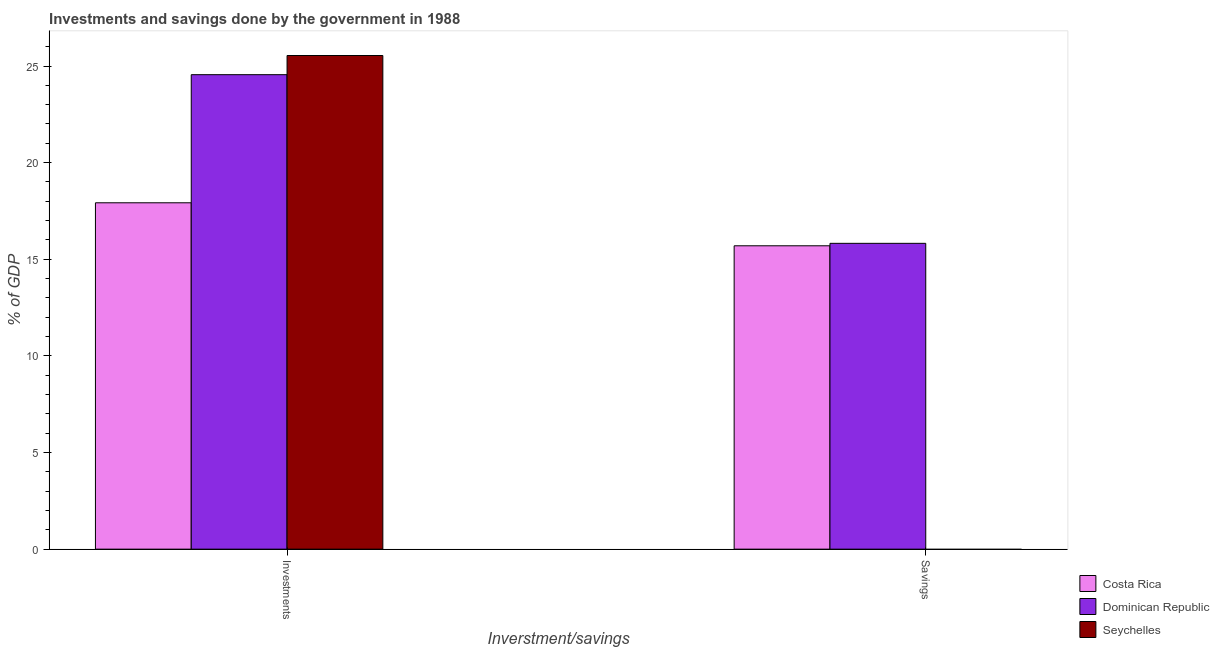Are the number of bars on each tick of the X-axis equal?
Give a very brief answer. No. How many bars are there on the 2nd tick from the left?
Your answer should be compact. 2. What is the label of the 1st group of bars from the left?
Provide a short and direct response. Investments. What is the savings of government in Dominican Republic?
Your response must be concise. 15.82. Across all countries, what is the maximum investments of government?
Provide a succinct answer. 25.54. In which country was the investments of government maximum?
Ensure brevity in your answer.  Seychelles. What is the total investments of government in the graph?
Your answer should be compact. 68.02. What is the difference between the investments of government in Costa Rica and that in Seychelles?
Make the answer very short. -7.62. What is the difference between the savings of government in Seychelles and the investments of government in Costa Rica?
Provide a succinct answer. -17.92. What is the average investments of government per country?
Offer a very short reply. 22.67. What is the difference between the investments of government and savings of government in Costa Rica?
Keep it short and to the point. 2.22. In how many countries, is the investments of government greater than 17 %?
Provide a succinct answer. 3. What is the ratio of the investments of government in Dominican Republic to that in Costa Rica?
Provide a succinct answer. 1.37. Is the investments of government in Costa Rica less than that in Seychelles?
Keep it short and to the point. Yes. In how many countries, is the savings of government greater than the average savings of government taken over all countries?
Ensure brevity in your answer.  2. How many bars are there?
Your response must be concise. 5. Are all the bars in the graph horizontal?
Provide a succinct answer. No. How many countries are there in the graph?
Your answer should be very brief. 3. Does the graph contain any zero values?
Your answer should be very brief. Yes. How many legend labels are there?
Give a very brief answer. 3. What is the title of the graph?
Keep it short and to the point. Investments and savings done by the government in 1988. Does "Qatar" appear as one of the legend labels in the graph?
Make the answer very short. No. What is the label or title of the X-axis?
Ensure brevity in your answer.  Inverstment/savings. What is the label or title of the Y-axis?
Provide a succinct answer. % of GDP. What is the % of GDP in Costa Rica in Investments?
Ensure brevity in your answer.  17.92. What is the % of GDP of Dominican Republic in Investments?
Your answer should be compact. 24.55. What is the % of GDP of Seychelles in Investments?
Keep it short and to the point. 25.54. What is the % of GDP in Costa Rica in Savings?
Give a very brief answer. 15.7. What is the % of GDP of Dominican Republic in Savings?
Offer a very short reply. 15.82. Across all Inverstment/savings, what is the maximum % of GDP in Costa Rica?
Give a very brief answer. 17.92. Across all Inverstment/savings, what is the maximum % of GDP of Dominican Republic?
Offer a very short reply. 24.55. Across all Inverstment/savings, what is the maximum % of GDP in Seychelles?
Provide a succinct answer. 25.54. Across all Inverstment/savings, what is the minimum % of GDP of Costa Rica?
Ensure brevity in your answer.  15.7. Across all Inverstment/savings, what is the minimum % of GDP of Dominican Republic?
Ensure brevity in your answer.  15.82. What is the total % of GDP in Costa Rica in the graph?
Make the answer very short. 33.62. What is the total % of GDP in Dominican Republic in the graph?
Provide a short and direct response. 40.37. What is the total % of GDP of Seychelles in the graph?
Offer a terse response. 25.54. What is the difference between the % of GDP of Costa Rica in Investments and that in Savings?
Offer a terse response. 2.22. What is the difference between the % of GDP of Dominican Republic in Investments and that in Savings?
Your response must be concise. 8.73. What is the difference between the % of GDP in Costa Rica in Investments and the % of GDP in Dominican Republic in Savings?
Offer a terse response. 2.1. What is the average % of GDP of Costa Rica per Inverstment/savings?
Your answer should be compact. 16.81. What is the average % of GDP in Dominican Republic per Inverstment/savings?
Ensure brevity in your answer.  20.19. What is the average % of GDP in Seychelles per Inverstment/savings?
Give a very brief answer. 12.77. What is the difference between the % of GDP in Costa Rica and % of GDP in Dominican Republic in Investments?
Provide a short and direct response. -6.63. What is the difference between the % of GDP in Costa Rica and % of GDP in Seychelles in Investments?
Ensure brevity in your answer.  -7.62. What is the difference between the % of GDP in Dominican Republic and % of GDP in Seychelles in Investments?
Offer a very short reply. -0.99. What is the difference between the % of GDP in Costa Rica and % of GDP in Dominican Republic in Savings?
Provide a succinct answer. -0.13. What is the ratio of the % of GDP of Costa Rica in Investments to that in Savings?
Provide a succinct answer. 1.14. What is the ratio of the % of GDP of Dominican Republic in Investments to that in Savings?
Keep it short and to the point. 1.55. What is the difference between the highest and the second highest % of GDP in Costa Rica?
Ensure brevity in your answer.  2.22. What is the difference between the highest and the second highest % of GDP of Dominican Republic?
Give a very brief answer. 8.73. What is the difference between the highest and the lowest % of GDP in Costa Rica?
Offer a very short reply. 2.22. What is the difference between the highest and the lowest % of GDP of Dominican Republic?
Provide a short and direct response. 8.73. What is the difference between the highest and the lowest % of GDP in Seychelles?
Your response must be concise. 25.54. 